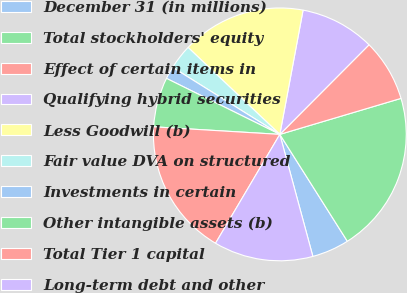Convert chart. <chart><loc_0><loc_0><loc_500><loc_500><pie_chart><fcel>December 31 (in millions)<fcel>Total stockholders' equity<fcel>Effect of certain items in<fcel>Qualifying hybrid securities<fcel>Less Goodwill (b)<fcel>Fair value DVA on structured<fcel>Investments in certain<fcel>Other intangible assets (b)<fcel>Total Tier 1 capital<fcel>Long-term debt and other<nl><fcel>4.76%<fcel>20.63%<fcel>7.94%<fcel>9.52%<fcel>15.87%<fcel>3.18%<fcel>1.59%<fcel>6.35%<fcel>17.46%<fcel>12.7%<nl></chart> 